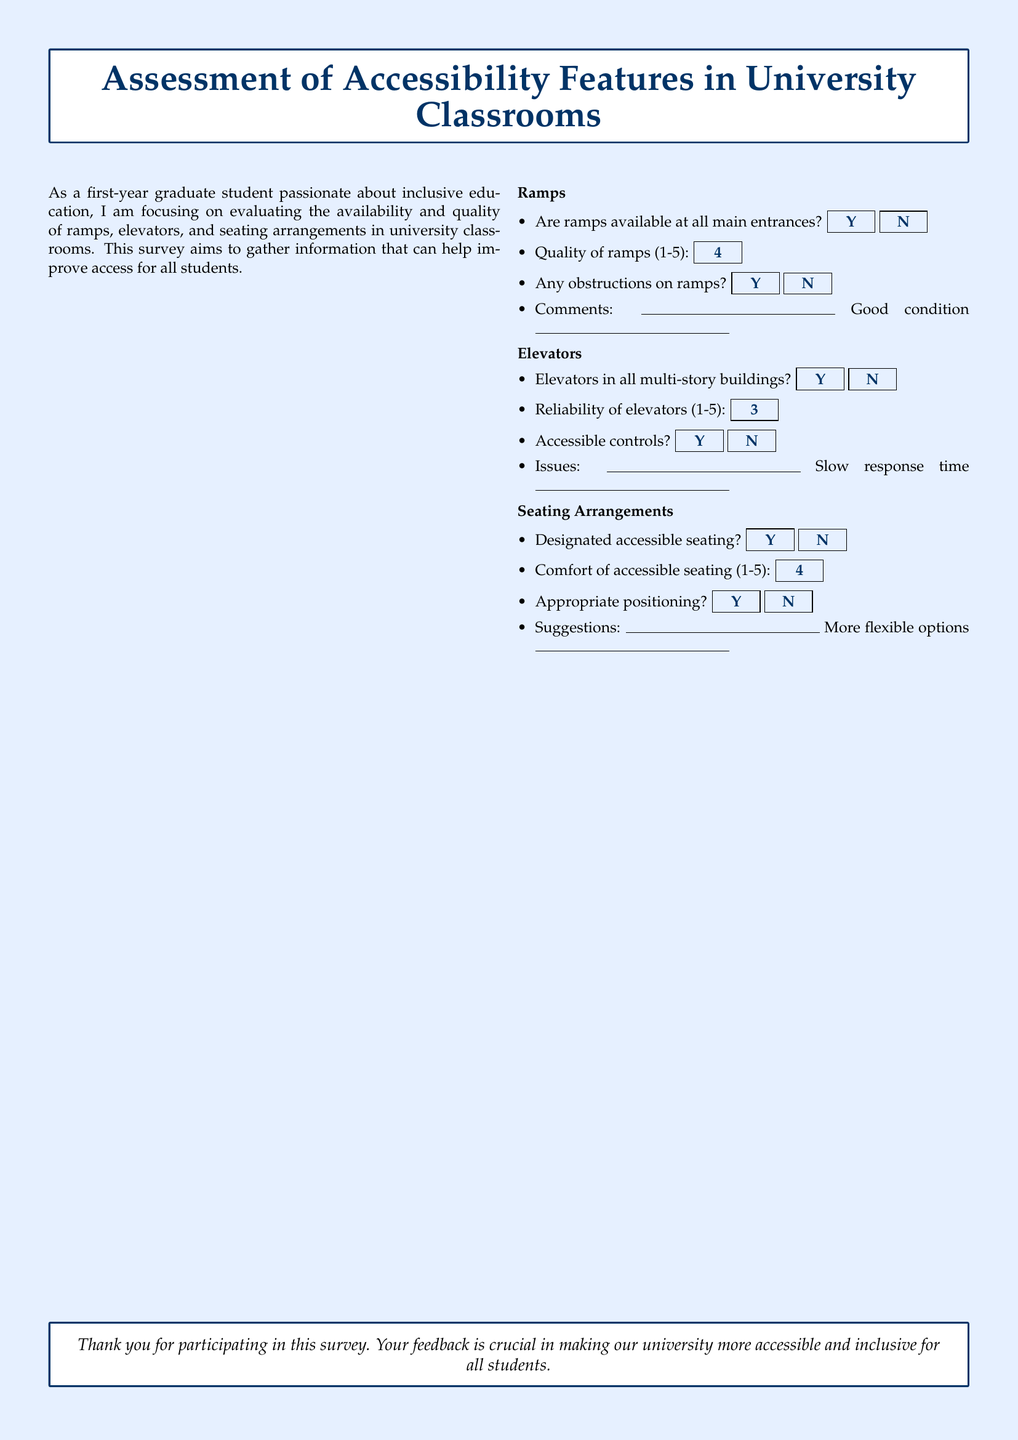Are ramps available at all main entrances? The survey explicitly asks about the availability of ramps at all main entrances.
Answer: Yes What is the quality rating of the ramps? The quality of ramps is rated on a scale from 1 to 5, and the rating provided in the survey is 4.
Answer: 4 Are elevators available in all multi-story buildings? The survey inquires whether elevators are present in all multi-story buildings as a yes/no question.
Answer: Yes What is the reliability rating of the elevators? The reliability of elevators is rated on a scale from 1 to 5, mentioned in the survey.
Answer: 3 Is there designated accessible seating? The survey asks if there is designated accessible seating available in classrooms.
Answer: Yes What is the comfort rating of the accessible seating? The comfort of accessible seating is evaluated on a scale from 1 to 5, as indicated in the document.
Answer: 4 Are the elevator controls accessible? The survey includes a question about whether the controls in the elevators are accessible to everyone.
Answer: Yes What issue is noted regarding elevators? The form allows for comments regarding elevator issues, providing insight into specific problems reported.
Answer: Slow response time What suggestion is made for seating arrangements? The survey includes a section for suggestions regarding seating, allowing respondents to provide feedback.
Answer: More flexible options Are there any obstructions on ramps? The survey asks if there are any obstructions present on the ramps.
Answer: No 